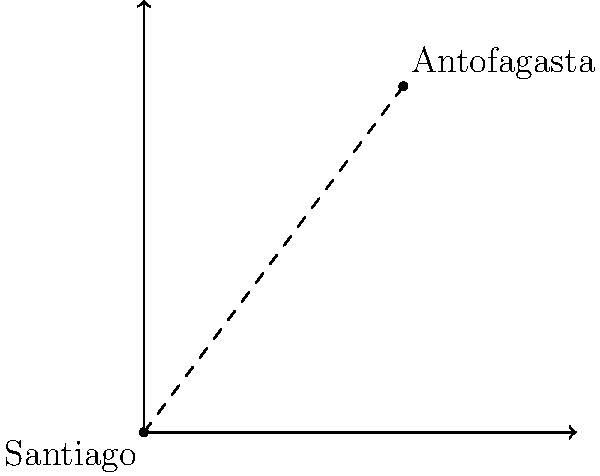On a 2D map of Chile, Santiago is represented at point (0,0) and Antofagasta at point (6,8). Each unit on the map represents 100 km. Calculate the straight-line distance between these two cities. To find the distance between Santiago and Antofagasta, we can use the distance formula derived from the Pythagorean theorem:

1) The distance formula is: $d = \sqrt{(x_2-x_1)^2 + (y_2-y_1)^2}$

2) Santiago's coordinates: $(x_1, y_1) = (0, 0)$
   Antofagasta's coordinates: $(x_2, y_2) = (6, 8)$

3) Plugging these into the formula:
   $d = \sqrt{(6-0)^2 + (8-0)^2}$

4) Simplify:
   $d = \sqrt{6^2 + 8^2}$

5) Calculate:
   $d = \sqrt{36 + 64} = \sqrt{100} = 10$

6) Since each unit represents 100 km:
   $10 \times 100 = 1000$ km

Therefore, the straight-line distance between Santiago and Antofagasta on this map is 1000 km.
Answer: 1000 km 